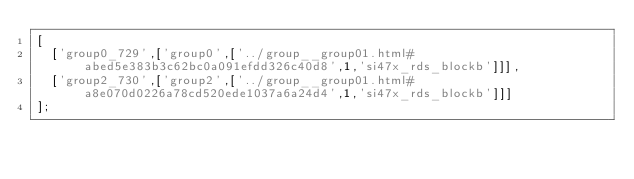<code> <loc_0><loc_0><loc_500><loc_500><_JavaScript_>[
  ['group0_729',['group0',['../group__group01.html#abed5e383b3c62bc0a091efdd326c40d8',1,'si47x_rds_blockb']]],
  ['group2_730',['group2',['../group__group01.html#a8e070d0226a78cd520ede1037a6a24d4',1,'si47x_rds_blockb']]]
];
</code> 